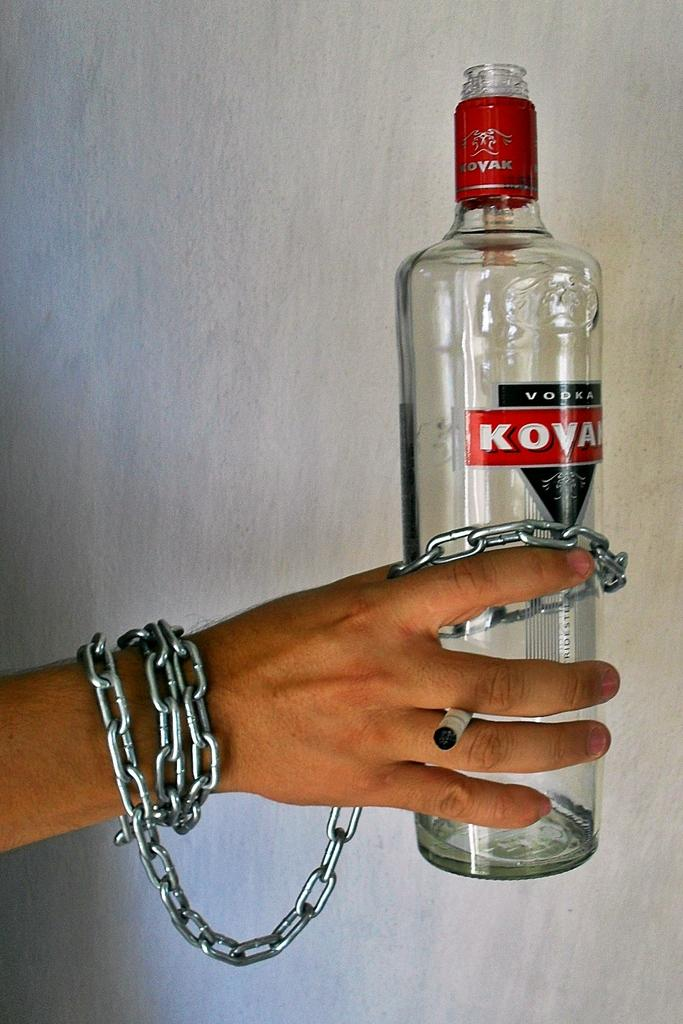<image>
Present a compact description of the photo's key features. A person with chains on their hand holds a bottle of vodka. 